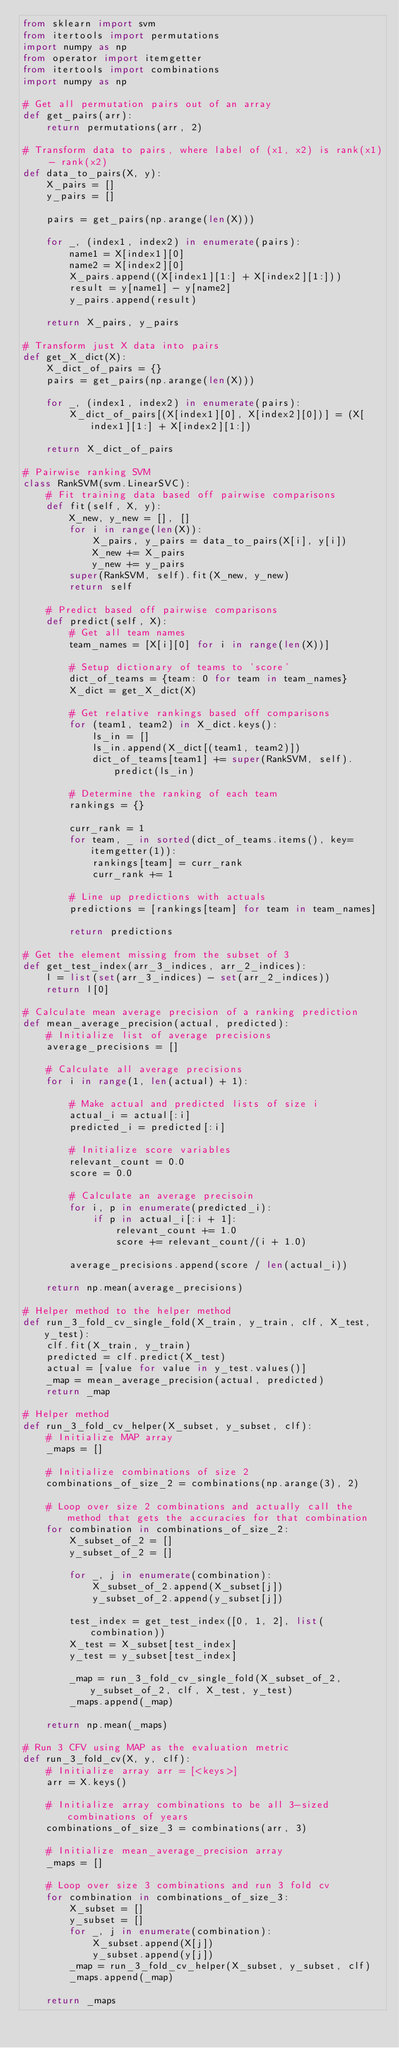Convert code to text. <code><loc_0><loc_0><loc_500><loc_500><_Python_>from sklearn import svm
from itertools import permutations
import numpy as np
from operator import itemgetter
from itertools import combinations    
import numpy as np

# Get all permutation pairs out of an array
def get_pairs(arr):
    return permutations(arr, 2)

# Transform data to pairs, where label of (x1, x2) is rank(x1) - rank(x2)
def data_to_pairs(X, y):
    X_pairs = [] 
    y_pairs = []
    
    pairs = get_pairs(np.arange(len(X)))
    
    for _, (index1, index2) in enumerate(pairs):
        name1 = X[index1][0]
        name2 = X[index2][0]
        X_pairs.append((X[index1][1:] + X[index2][1:]))
        result = y[name1] - y[name2]
        y_pairs.append(result)
            
    return X_pairs, y_pairs

# Transform just X data into pairs
def get_X_dict(X):
    X_dict_of_pairs = {}
    pairs = get_pairs(np.arange(len(X)))
    
    for _, (index1, index2) in enumerate(pairs):
        X_dict_of_pairs[(X[index1][0], X[index2][0])] = (X[index1][1:] + X[index2][1:])
        
    return X_dict_of_pairs

# Pairwise ranking SVM
class RankSVM(svm.LinearSVC):
    # Fit training data based off pairwise comparisons
    def fit(self, X, y):
        X_new, y_new = [], []
        for i in range(len(X)):
            X_pairs, y_pairs = data_to_pairs(X[i], y[i])
            X_new += X_pairs
            y_new += y_pairs
        super(RankSVM, self).fit(X_new, y_new)
        return self
    
    # Predict based off pairwise comparisons
    def predict(self, X):
        # Get all team names
        team_names = [X[i][0] for i in range(len(X))]
        
        # Setup dictionary of teams to 'score'
        dict_of_teams = {team: 0 for team in team_names}
        X_dict = get_X_dict(X)
        
        # Get relative rankings based off comparisons
        for (team1, team2) in X_dict.keys():
            ls_in = []
            ls_in.append(X_dict[(team1, team2)])
            dict_of_teams[team1] += super(RankSVM, self).predict(ls_in)
                
        # Determine the ranking of each team
        rankings = {}
        
        curr_rank = 1
        for team, _ in sorted(dict_of_teams.items(), key=itemgetter(1)):
            rankings[team] = curr_rank
            curr_rank += 1
        
        # Line up predictions with actuals
        predictions = [rankings[team] for team in team_names]
        
        return predictions

# Get the element missing from the subset of 3
def get_test_index(arr_3_indices, arr_2_indices):
    l = list(set(arr_3_indices) - set(arr_2_indices))
    return l[0]

# Calculate mean average precision of a ranking prediction
def mean_average_precision(actual, predicted):
    # Initialize list of average precisions
    average_precisions = []
    
    # Calculate all average precisions
    for i in range(1, len(actual) + 1):
        
        # Make actual and predicted lists of size i
        actual_i = actual[:i]
        predicted_i = predicted[:i]
        
        # Initialize score variables
        relevant_count = 0.0
        score = 0.0

        # Calculate an average precisoin
        for i, p in enumerate(predicted_i):
            if p in actual_i[:i + 1]:
                relevant_count += 1.0
                score += relevant_count/(i + 1.0)
            
        average_precisions.append(score / len(actual_i))
    
    return np.mean(average_precisions)

# Helper method to the helper method
def run_3_fold_cv_single_fold(X_train, y_train, clf, X_test, y_test):
    clf.fit(X_train, y_train)
    predicted = clf.predict(X_test)
    actual = [value for value in y_test.values()]
    _map = mean_average_precision(actual, predicted)
    return _map

# Helper method
def run_3_fold_cv_helper(X_subset, y_subset, clf):
    # Initialize MAP array
    _maps = []
    
    # Initialize combinations of size 2
    combinations_of_size_2 = combinations(np.arange(3), 2)
    
    # Loop over size 2 combinations and actually call the method that gets the accuracies for that combination
    for combination in combinations_of_size_2:
        X_subset_of_2 = []
        y_subset_of_2 = []
        
        for _, j in enumerate(combination):
            X_subset_of_2.append(X_subset[j])
            y_subset_of_2.append(y_subset[j])
            
        test_index = get_test_index([0, 1, 2], list(combination))
        X_test = X_subset[test_index]
        y_test = y_subset[test_index]
        
        _map = run_3_fold_cv_single_fold(X_subset_of_2, y_subset_of_2, clf, X_test, y_test)
        _maps.append(_map)
        
    return np.mean(_maps)

# Run 3 CFV using MAP as the evaluation metric
def run_3_fold_cv(X, y, clf):
    # Initialize array arr = [<keys>]
    arr = X.keys()
    
    # Initialize array combinations to be all 3-sized combinations of years
    combinations_of_size_3 = combinations(arr, 3)
    
    # Initialize mean_average_precision array
    _maps = []
    
    # Loop over size 3 combinations and run 3 fold cv
    for combination in combinations_of_size_3:
        X_subset = []
        y_subset = []
        for _, j in enumerate(combination):
            X_subset.append(X[j])
            y_subset.append(y[j])
        _map = run_3_fold_cv_helper(X_subset, y_subset, clf)
        _maps.append(_map)
            
    return _maps</code> 